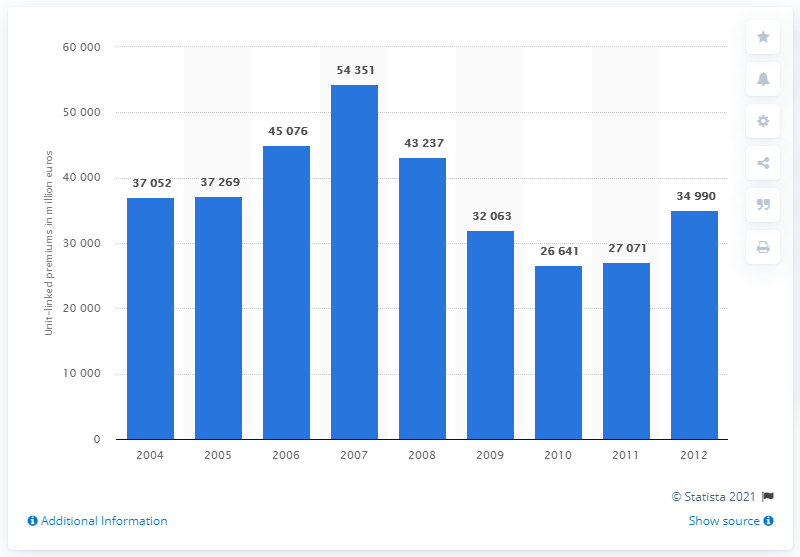Indicate a few pertinent items in this graphic. In 2012, the premiums for the unit-linked contract amounted to a total of 34,990. 